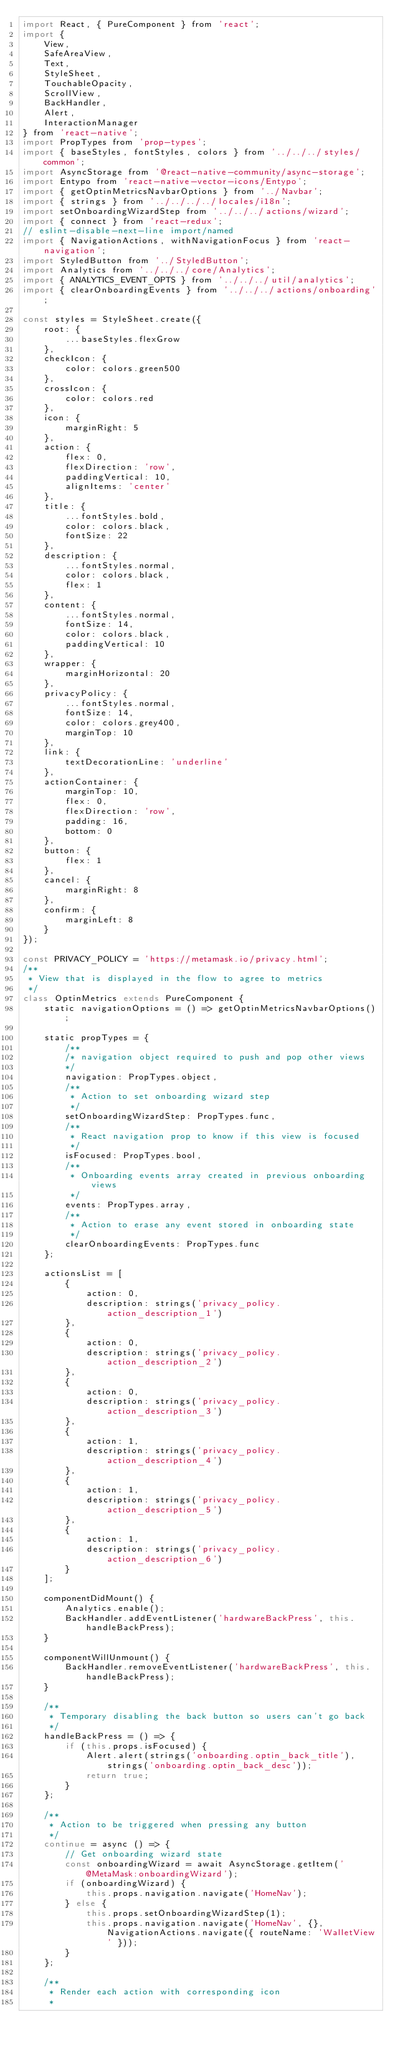<code> <loc_0><loc_0><loc_500><loc_500><_JavaScript_>import React, { PureComponent } from 'react';
import {
	View,
	SafeAreaView,
	Text,
	StyleSheet,
	TouchableOpacity,
	ScrollView,
	BackHandler,
	Alert,
	InteractionManager
} from 'react-native';
import PropTypes from 'prop-types';
import { baseStyles, fontStyles, colors } from '../../../styles/common';
import AsyncStorage from '@react-native-community/async-storage';
import Entypo from 'react-native-vector-icons/Entypo';
import { getOptinMetricsNavbarOptions } from '../Navbar';
import { strings } from '../../../../locales/i18n';
import setOnboardingWizardStep from '../../../actions/wizard';
import { connect } from 'react-redux';
// eslint-disable-next-line import/named
import { NavigationActions, withNavigationFocus } from 'react-navigation';
import StyledButton from '../StyledButton';
import Analytics from '../../../core/Analytics';
import { ANALYTICS_EVENT_OPTS } from '../../../util/analytics';
import { clearOnboardingEvents } from '../../../actions/onboarding';

const styles = StyleSheet.create({
	root: {
		...baseStyles.flexGrow
	},
	checkIcon: {
		color: colors.green500
	},
	crossIcon: {
		color: colors.red
	},
	icon: {
		marginRight: 5
	},
	action: {
		flex: 0,
		flexDirection: 'row',
		paddingVertical: 10,
		alignItems: 'center'
	},
	title: {
		...fontStyles.bold,
		color: colors.black,
		fontSize: 22
	},
	description: {
		...fontStyles.normal,
		color: colors.black,
		flex: 1
	},
	content: {
		...fontStyles.normal,
		fontSize: 14,
		color: colors.black,
		paddingVertical: 10
	},
	wrapper: {
		marginHorizontal: 20
	},
	privacyPolicy: {
		...fontStyles.normal,
		fontSize: 14,
		color: colors.grey400,
		marginTop: 10
	},
	link: {
		textDecorationLine: 'underline'
	},
	actionContainer: {
		marginTop: 10,
		flex: 0,
		flexDirection: 'row',
		padding: 16,
		bottom: 0
	},
	button: {
		flex: 1
	},
	cancel: {
		marginRight: 8
	},
	confirm: {
		marginLeft: 8
	}
});

const PRIVACY_POLICY = 'https://metamask.io/privacy.html';
/**
 * View that is displayed in the flow to agree to metrics
 */
class OptinMetrics extends PureComponent {
	static navigationOptions = () => getOptinMetricsNavbarOptions();

	static propTypes = {
		/**
		/* navigation object required to push and pop other views
		*/
		navigation: PropTypes.object,
		/**
		 * Action to set onboarding wizard step
		 */
		setOnboardingWizardStep: PropTypes.func,
		/**
		 * React navigation prop to know if this view is focused
		 */
		isFocused: PropTypes.bool,
		/**
		 * Onboarding events array created in previous onboarding views
		 */
		events: PropTypes.array,
		/**
		 * Action to erase any event stored in onboarding state
		 */
		clearOnboardingEvents: PropTypes.func
	};

	actionsList = [
		{
			action: 0,
			description: strings('privacy_policy.action_description_1')
		},
		{
			action: 0,
			description: strings('privacy_policy.action_description_2')
		},
		{
			action: 0,
			description: strings('privacy_policy.action_description_3')
		},
		{
			action: 1,
			description: strings('privacy_policy.action_description_4')
		},
		{
			action: 1,
			description: strings('privacy_policy.action_description_5')
		},
		{
			action: 1,
			description: strings('privacy_policy.action_description_6')
		}
	];

	componentDidMount() {
		Analytics.enable();
		BackHandler.addEventListener('hardwareBackPress', this.handleBackPress);
	}

	componentWillUnmount() {
		BackHandler.removeEventListener('hardwareBackPress', this.handleBackPress);
	}

	/**
	 * Temporary disabling the back button so users can't go back
	 */
	handleBackPress = () => {
		if (this.props.isFocused) {
			Alert.alert(strings('onboarding.optin_back_title'), strings('onboarding.optin_back_desc'));
			return true;
		}
	};

	/**
	 * Action to be triggered when pressing any button
	 */
	continue = async () => {
		// Get onboarding wizard state
		const onboardingWizard = await AsyncStorage.getItem('@MetaMask:onboardingWizard');
		if (onboardingWizard) {
			this.props.navigation.navigate('HomeNav');
		} else {
			this.props.setOnboardingWizardStep(1);
			this.props.navigation.navigate('HomeNav', {}, NavigationActions.navigate({ routeName: 'WalletView' }));
		}
	};

	/**
	 * Render each action with corresponding icon
	 *</code> 